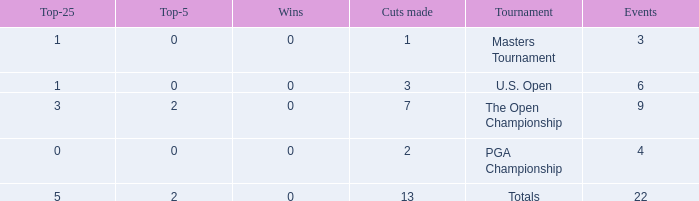What is the fewest number of top-25s for events with more than 13 cuts made? None. 